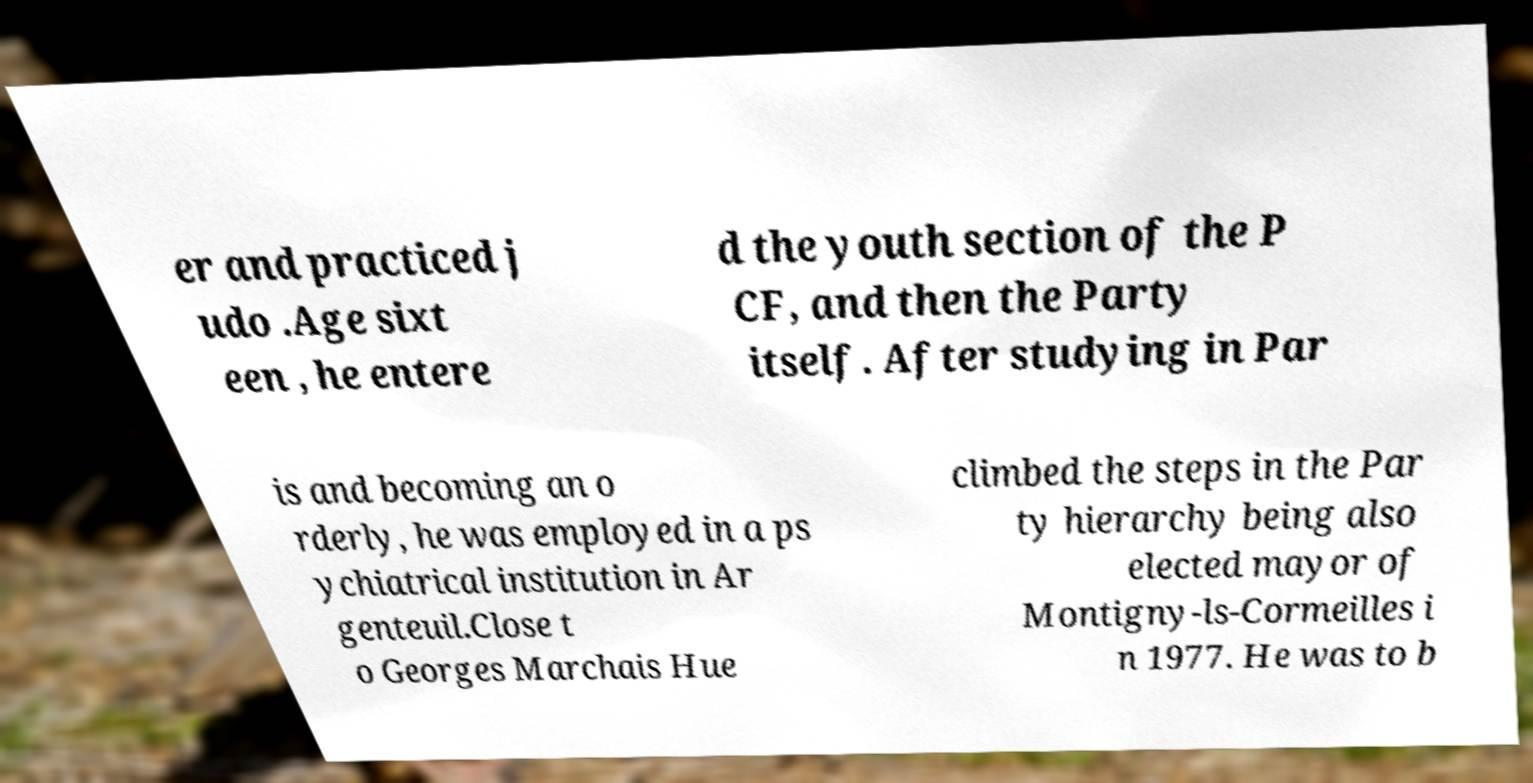What messages or text are displayed in this image? I need them in a readable, typed format. er and practiced j udo .Age sixt een , he entere d the youth section of the P CF, and then the Party itself. After studying in Par is and becoming an o rderly, he was employed in a ps ychiatrical institution in Ar genteuil.Close t o Georges Marchais Hue climbed the steps in the Par ty hierarchy being also elected mayor of Montigny-ls-Cormeilles i n 1977. He was to b 